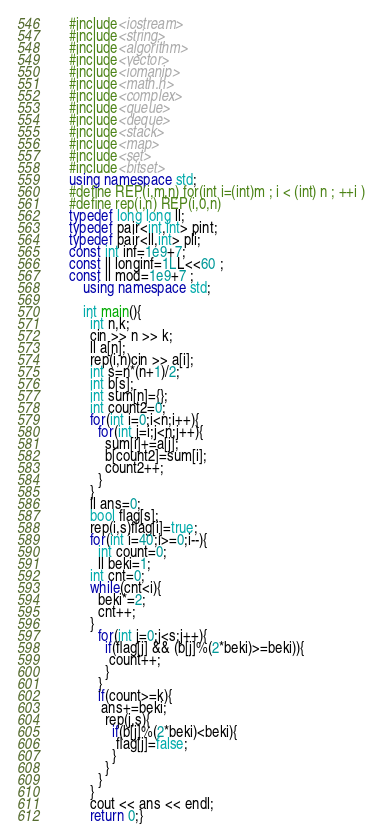<code> <loc_0><loc_0><loc_500><loc_500><_C++_>    #include<iostream>
    #include<string>
    #include<algorithm>
    #include<vector>
    #include<iomanip>
    #include<math.h>
    #include<complex>
    #include<queue>
    #include<deque>
    #include<stack>
    #include<map>
    #include<set>
    #include<bitset>
    using namespace std;
    #define REP(i,m,n) for(int i=(int)m ; i < (int) n ; ++i )
    #define rep(i,n) REP(i,0,n)
    typedef long long ll;
    typedef pair<int,int> pint;
    typedef pair<ll,int> pli;
    const int inf=1e9+7;
    const ll longinf=1LL<<60 ;
    const ll mod=1e9+7 ;
        using namespace std;
     
        int main(){
          int n,k;
          cin >> n >> k;
          ll a[n];
          rep(i,n)cin >> a[i];
          int s=n*(n+1)/2;
          int b[s];
          int sum[n]={};
          int count2=0;
          for(int i=0;i<n;i++){
            for(int j=i;j<n;j++){
              sum[i]+=a[j];
              b[count2]=sum[i];
              count2++;
            }
          }
          ll ans=0;
          bool flag[s];
          rep(i,s)flag[i]=true;
          for(int i=40;i>=0;i--){
            int count=0;
            ll beki=1;
          int cnt=0;
          while(cnt<i){
            beki*=2;
            cnt++;
          }
            for(int j=0;j<s;j++){
              if(flag[j] && (b[j]%(2*beki)>=beki)){
               count++;
              }
            }
            if(count>=k){
             ans+=beki;
              rep(j,s){
                if(b[j]%(2*beki)<beki){
                 flag[j]=false; 
                }
              }
            }
          }
          cout << ans << endl;
          return 0;}</code> 